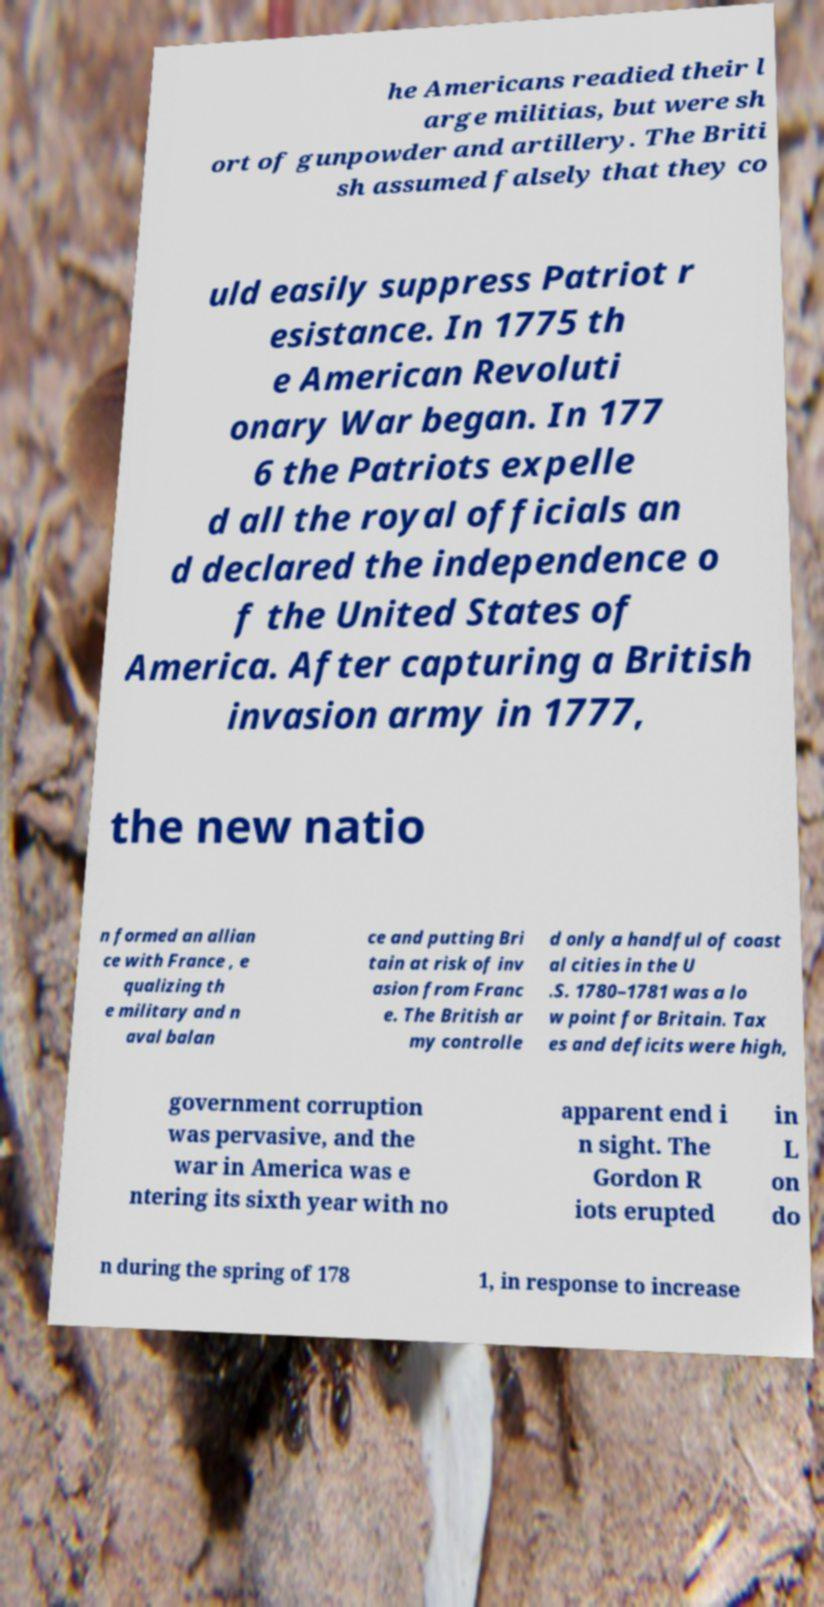What messages or text are displayed in this image? I need them in a readable, typed format. he Americans readied their l arge militias, but were sh ort of gunpowder and artillery. The Briti sh assumed falsely that they co uld easily suppress Patriot r esistance. In 1775 th e American Revoluti onary War began. In 177 6 the Patriots expelle d all the royal officials an d declared the independence o f the United States of America. After capturing a British invasion army in 1777, the new natio n formed an allian ce with France , e qualizing th e military and n aval balan ce and putting Bri tain at risk of inv asion from Franc e. The British ar my controlle d only a handful of coast al cities in the U .S. 1780–1781 was a lo w point for Britain. Tax es and deficits were high, government corruption was pervasive, and the war in America was e ntering its sixth year with no apparent end i n sight. The Gordon R iots erupted in L on do n during the spring of 178 1, in response to increase 